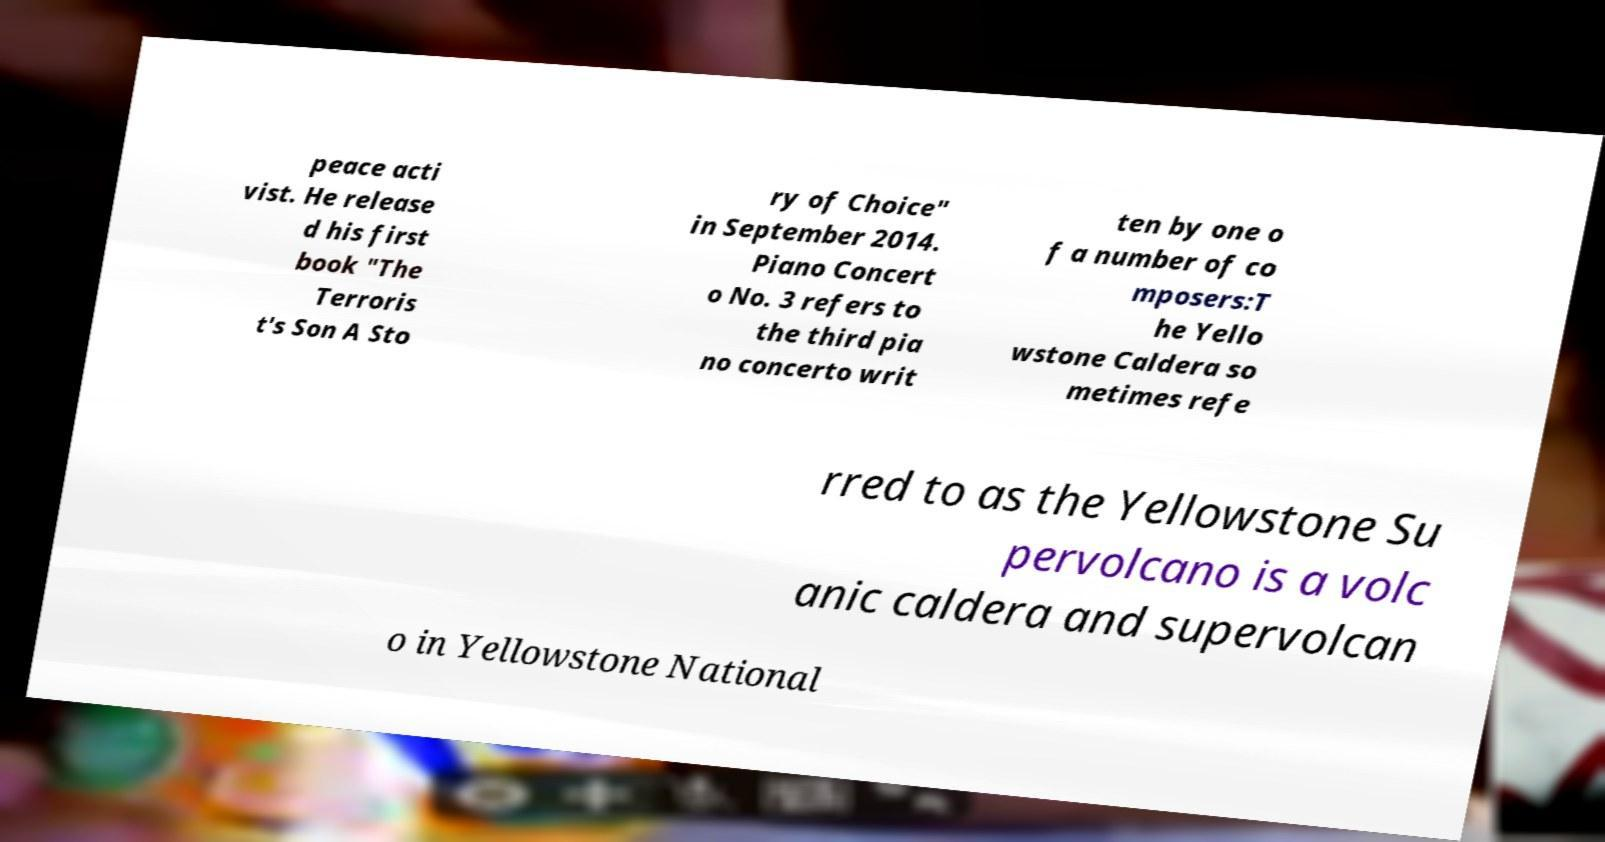Please identify and transcribe the text found in this image. peace acti vist. He release d his first book "The Terroris t's Son A Sto ry of Choice" in September 2014. Piano Concert o No. 3 refers to the third pia no concerto writ ten by one o f a number of co mposers:T he Yello wstone Caldera so metimes refe rred to as the Yellowstone Su pervolcano is a volc anic caldera and supervolcan o in Yellowstone National 